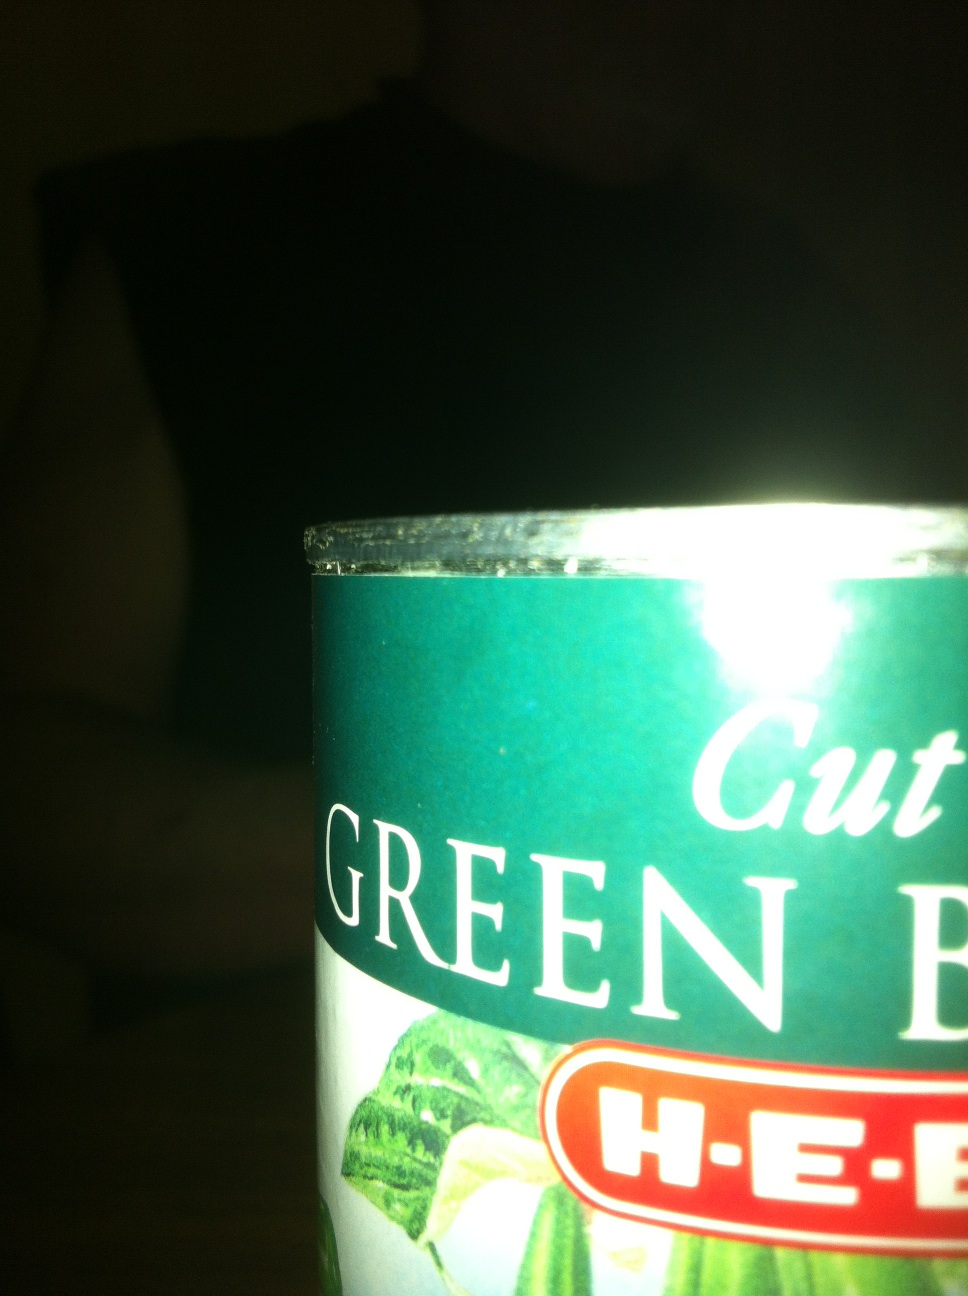What is this canned good please? Thank you. from Vizwiz cut green beans 